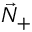<formula> <loc_0><loc_0><loc_500><loc_500>\vec { N } _ { + }</formula> 